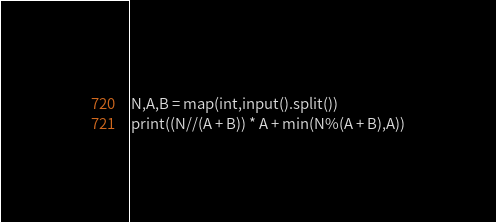<code> <loc_0><loc_0><loc_500><loc_500><_Python_>N,A,B = map(int,input().split())
print((N//(A + B)) * A + min(N%(A + B),A))</code> 